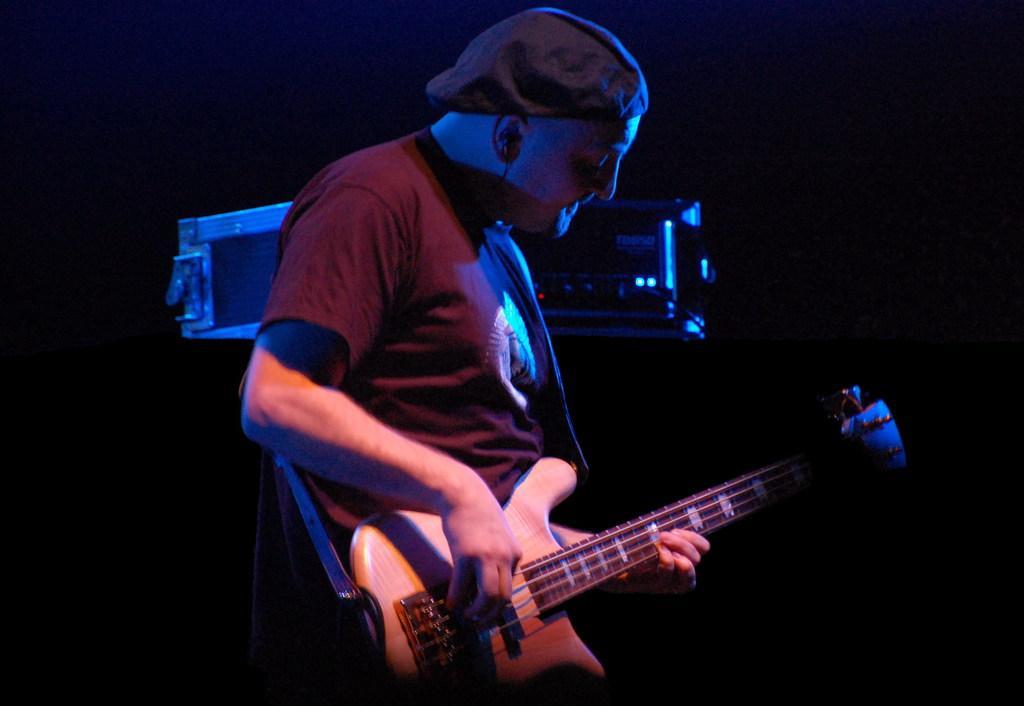Describe this image in one or two sentences. Here we can see a man playing guitar and there is a musical instrument. There is a dark background. 